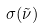<formula> <loc_0><loc_0><loc_500><loc_500>\sigma ( \tilde { \nu } )</formula> 